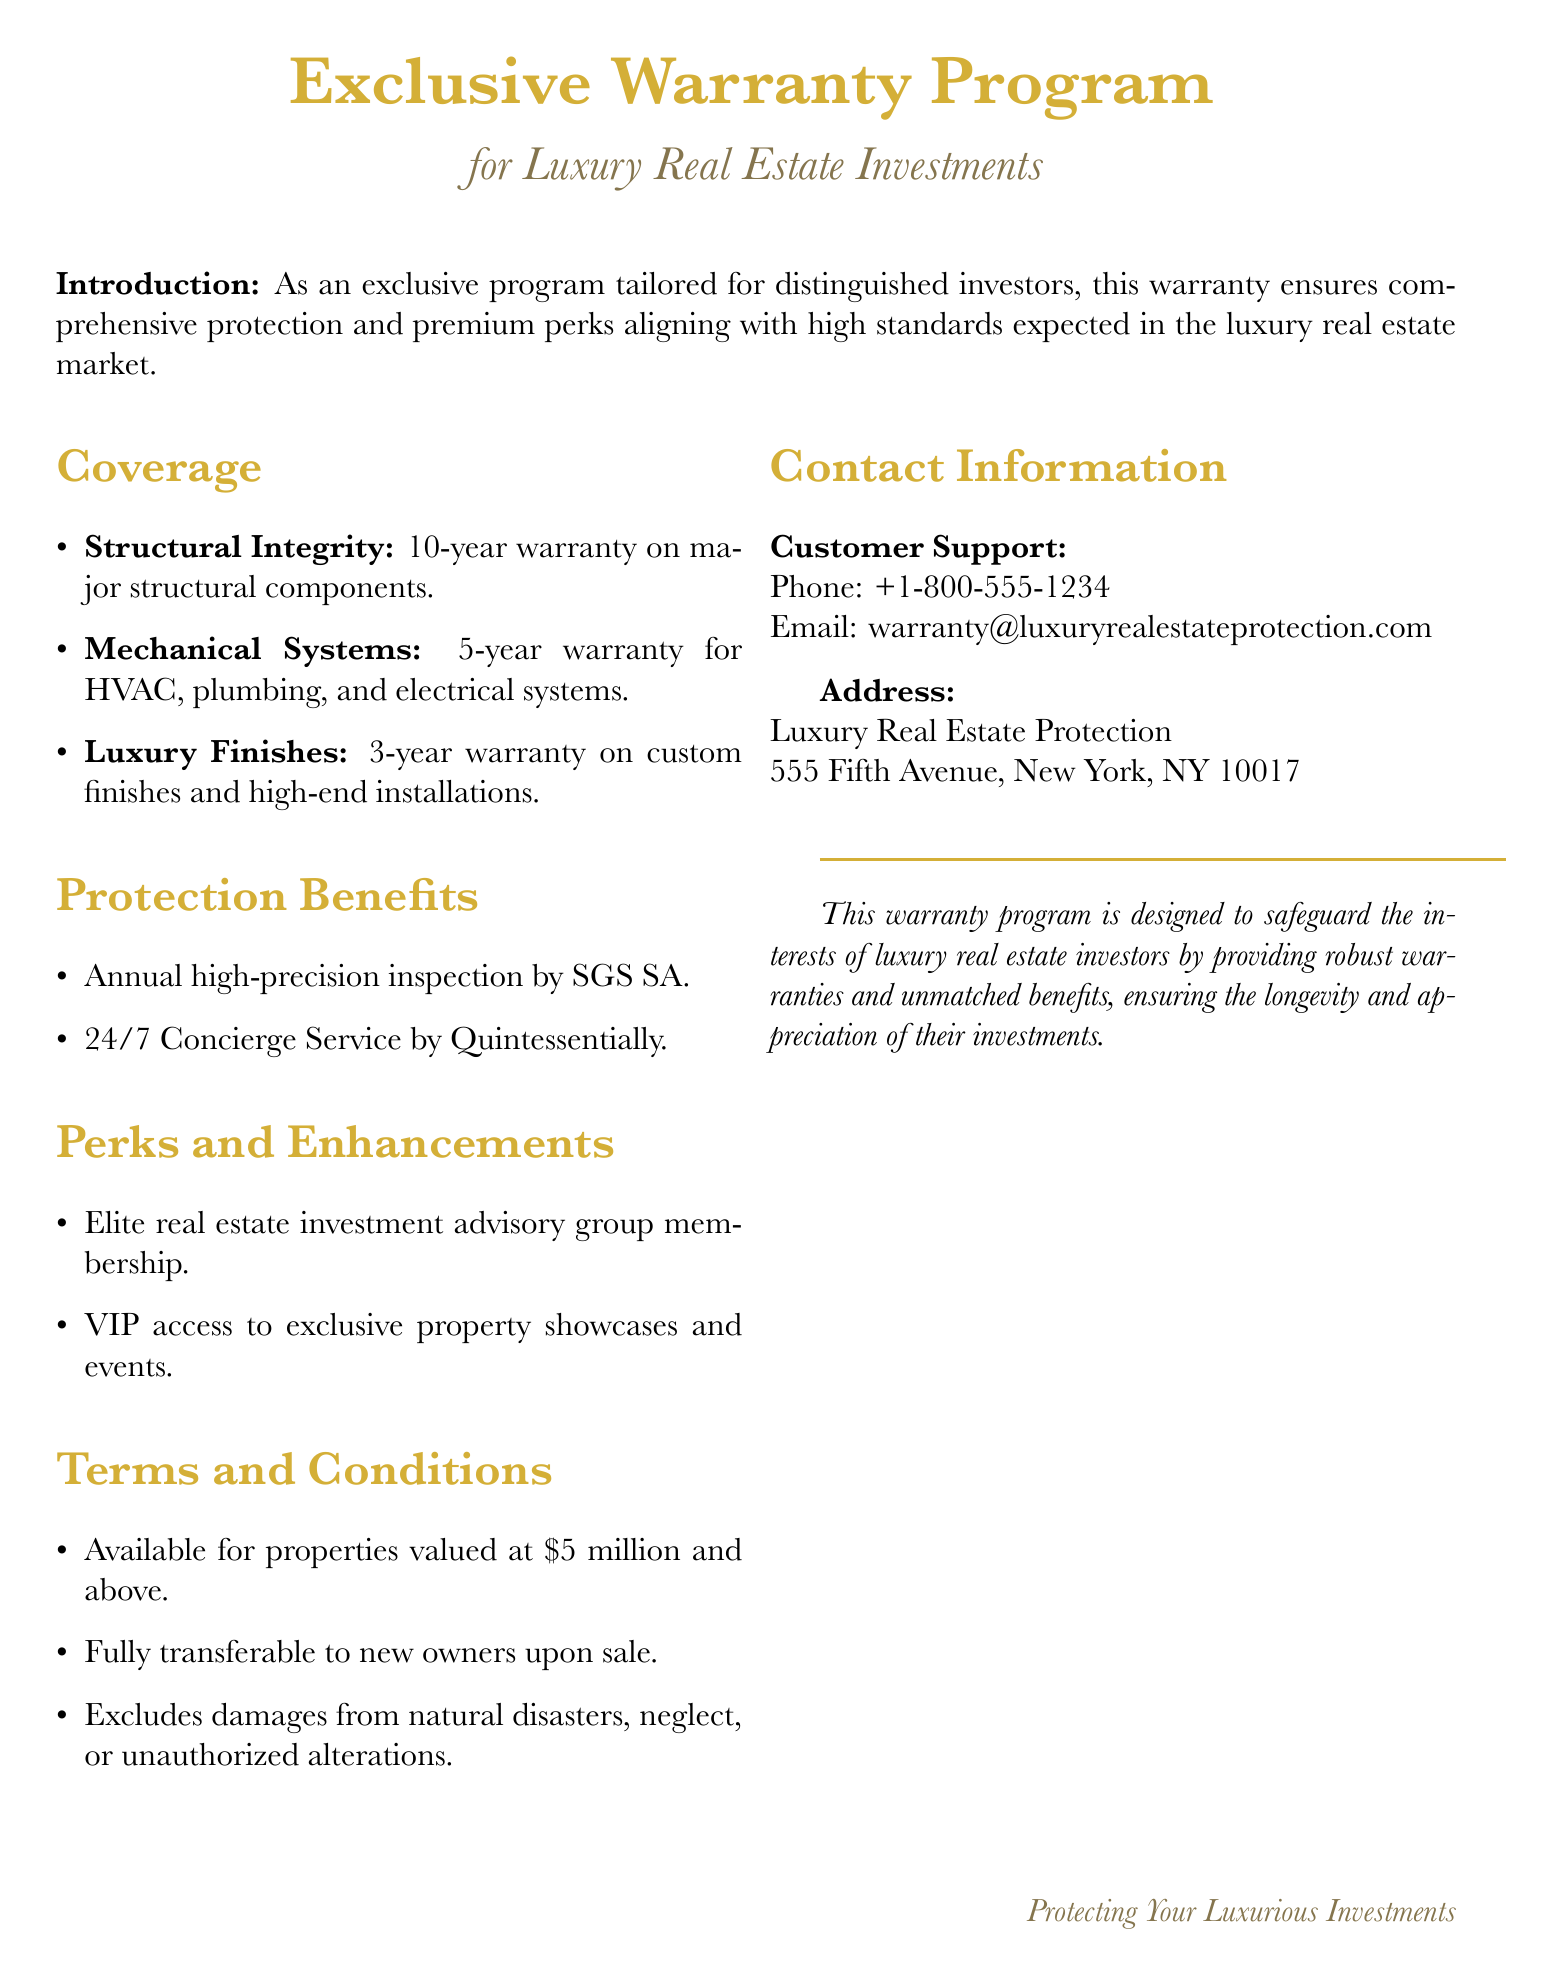what is the warranty on major structural components? The warranty for major structural components is explicitly stated in the document, which is 10 years.
Answer: 10 years what is the coverage duration for luxury finishes? The document specifies the warranty duration for luxury finishes, which is 3 years.
Answer: 3 years who provides the annual inspection? The document mentions a specific company responsible for the annual inspection, which is SGS SA.
Answer: SGS SA what is the value threshold for properties to be eligible for this warranty? The document indicates a minimum property value for eligibility, which is \$5 million.
Answer: \$5 million are damages from natural disasters covered? The terms and conditions in the document explicitly state exclusions, including damages from natural disasters.
Answer: No how long is the warranty for HVAC systems? The document clearly states the duration of the warranty for HVAC systems, which is 5 years.
Answer: 5 years who offers the concierge service? The document mentions the provider of the concierge service, which is Quintessentially.
Answer: Quintessentially what type of events do members get VIP access to? The document refers to members receiving VIP access related to exclusive property showcases and events.
Answer: Exclusive property showcases and events can the warranty be transferred to new owners? The document includes a condition regarding transferability of the warranty upon sale, confirming that it can be transferred.
Answer: Yes 